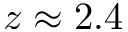Convert formula to latex. <formula><loc_0><loc_0><loc_500><loc_500>z \approx 2 . 4</formula> 